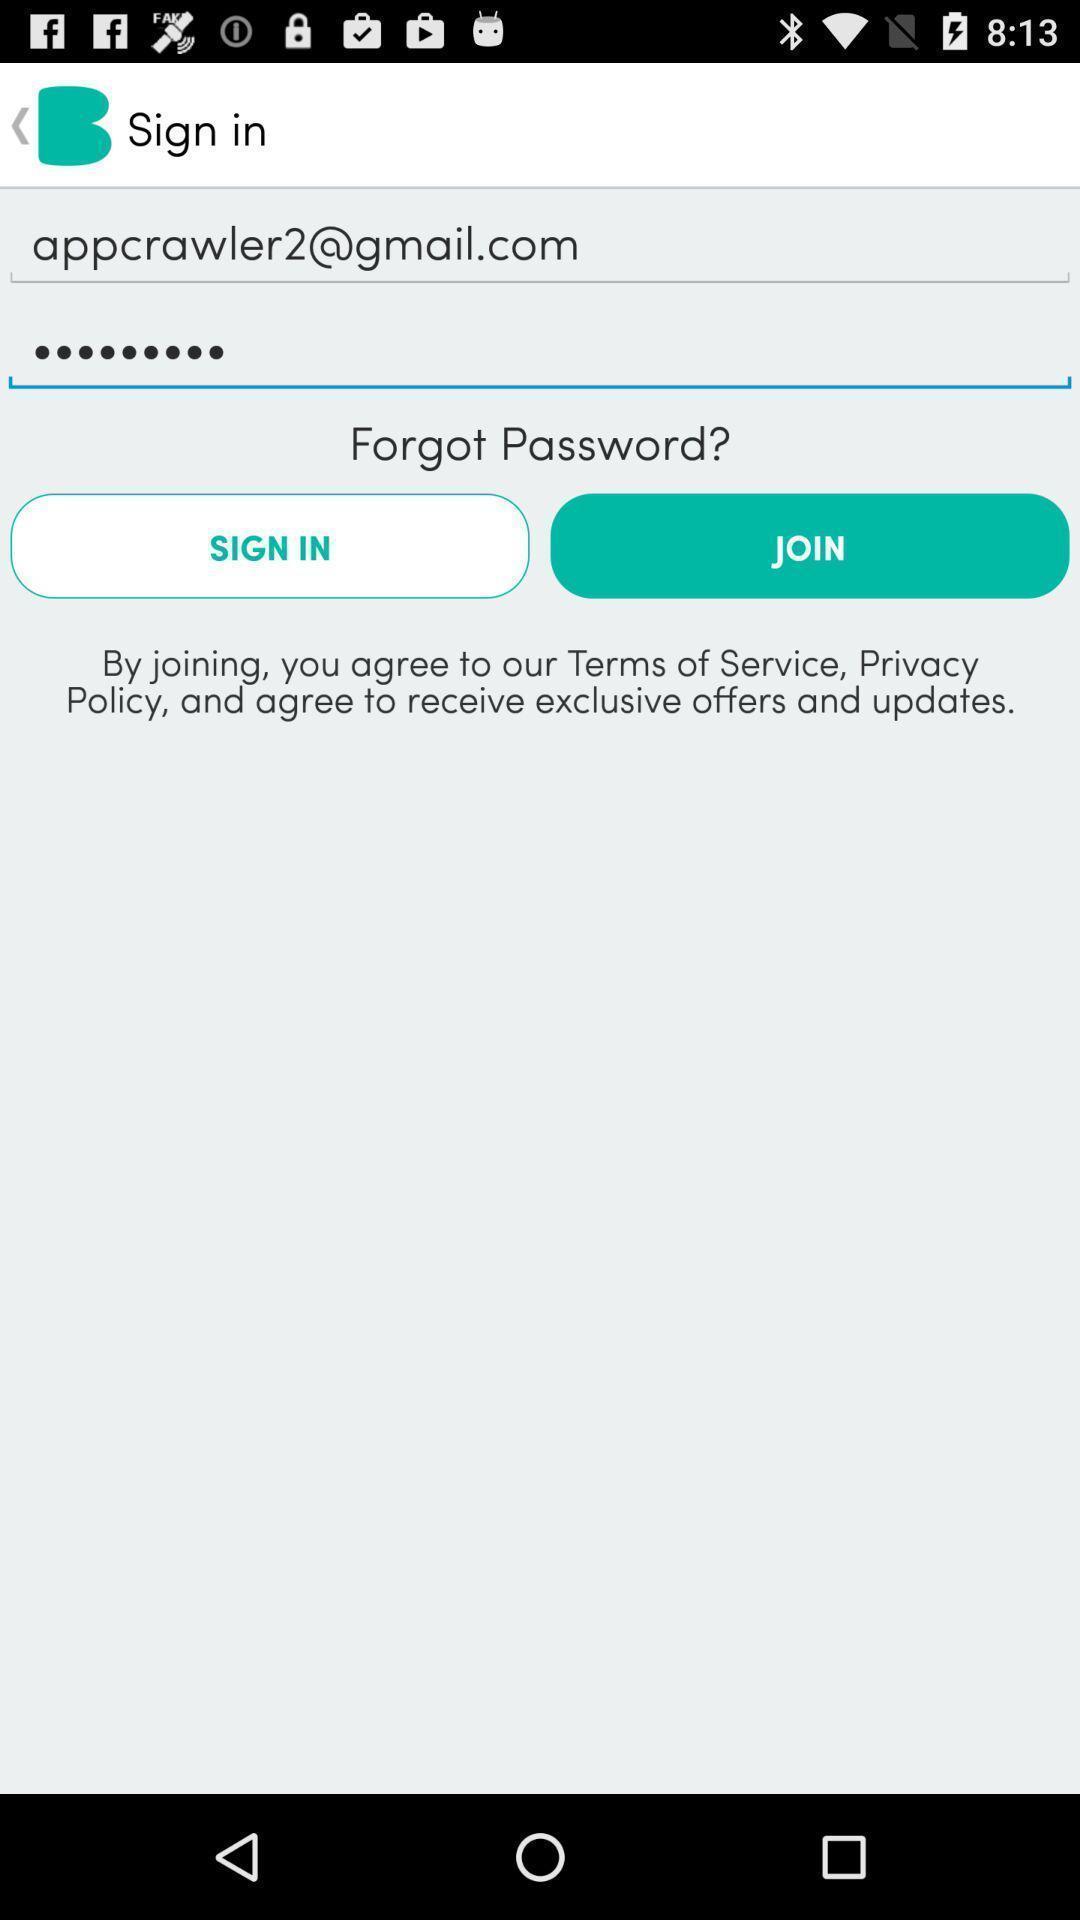Please provide a description for this image. Sign in page. 